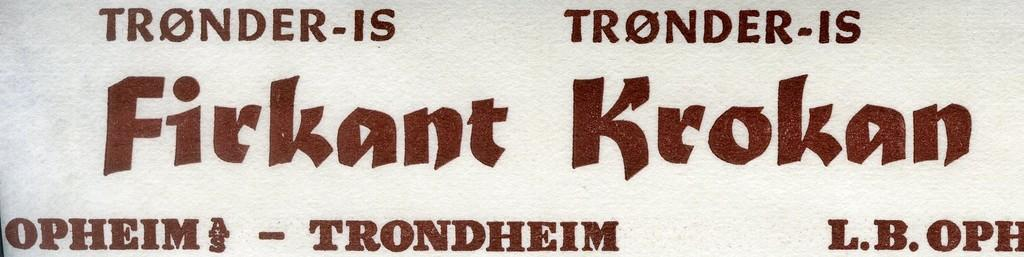Provide a one-sentence caption for the provided image. A label that seems to be in norwegian with the word trondheim at the bottom. 